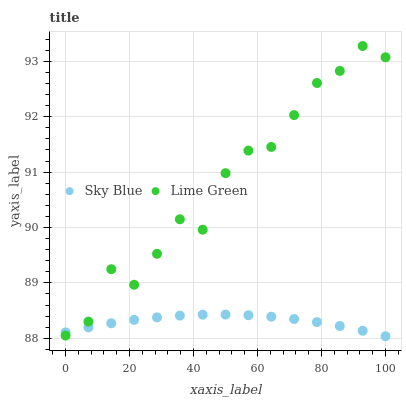Does Sky Blue have the minimum area under the curve?
Answer yes or no. Yes. Does Lime Green have the maximum area under the curve?
Answer yes or no. Yes. Does Lime Green have the minimum area under the curve?
Answer yes or no. No. Is Sky Blue the smoothest?
Answer yes or no. Yes. Is Lime Green the roughest?
Answer yes or no. Yes. Is Lime Green the smoothest?
Answer yes or no. No. Does Sky Blue have the lowest value?
Answer yes or no. Yes. Does Lime Green have the lowest value?
Answer yes or no. No. Does Lime Green have the highest value?
Answer yes or no. Yes. Does Sky Blue intersect Lime Green?
Answer yes or no. Yes. Is Sky Blue less than Lime Green?
Answer yes or no. No. Is Sky Blue greater than Lime Green?
Answer yes or no. No. 